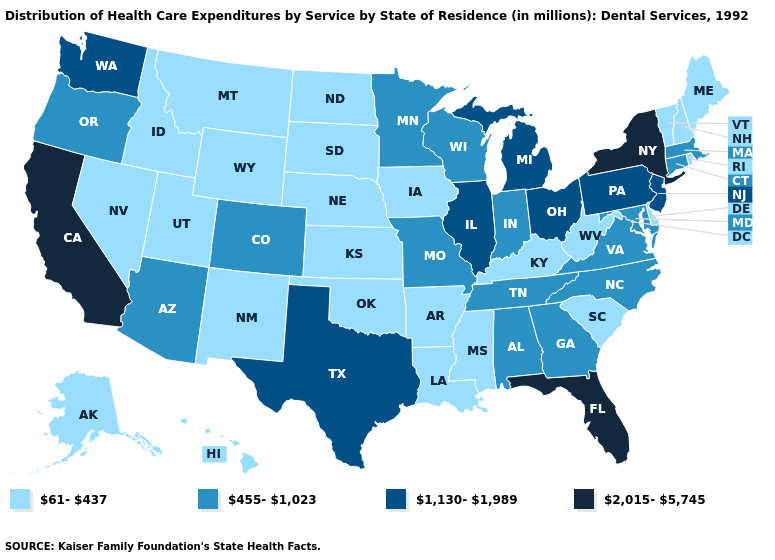Does California have the highest value in the USA?
Concise answer only. Yes. Name the states that have a value in the range 2,015-5,745?
Be succinct. California, Florida, New York. What is the value of Louisiana?
Give a very brief answer. 61-437. Name the states that have a value in the range 61-437?
Give a very brief answer. Alaska, Arkansas, Delaware, Hawaii, Idaho, Iowa, Kansas, Kentucky, Louisiana, Maine, Mississippi, Montana, Nebraska, Nevada, New Hampshire, New Mexico, North Dakota, Oklahoma, Rhode Island, South Carolina, South Dakota, Utah, Vermont, West Virginia, Wyoming. What is the value of Georgia?
Write a very short answer. 455-1,023. What is the value of Utah?
Give a very brief answer. 61-437. What is the lowest value in the Northeast?
Be succinct. 61-437. Which states have the highest value in the USA?
Short answer required. California, Florida, New York. Name the states that have a value in the range 1,130-1,989?
Keep it brief. Illinois, Michigan, New Jersey, Ohio, Pennsylvania, Texas, Washington. Name the states that have a value in the range 61-437?
Be succinct. Alaska, Arkansas, Delaware, Hawaii, Idaho, Iowa, Kansas, Kentucky, Louisiana, Maine, Mississippi, Montana, Nebraska, Nevada, New Hampshire, New Mexico, North Dakota, Oklahoma, Rhode Island, South Carolina, South Dakota, Utah, Vermont, West Virginia, Wyoming. Among the states that border Delaware , does New Jersey have the highest value?
Write a very short answer. Yes. Among the states that border Massachusetts , which have the lowest value?
Concise answer only. New Hampshire, Rhode Island, Vermont. Name the states that have a value in the range 455-1,023?
Answer briefly. Alabama, Arizona, Colorado, Connecticut, Georgia, Indiana, Maryland, Massachusetts, Minnesota, Missouri, North Carolina, Oregon, Tennessee, Virginia, Wisconsin. What is the value of Wyoming?
Short answer required. 61-437. Does the first symbol in the legend represent the smallest category?
Short answer required. Yes. 